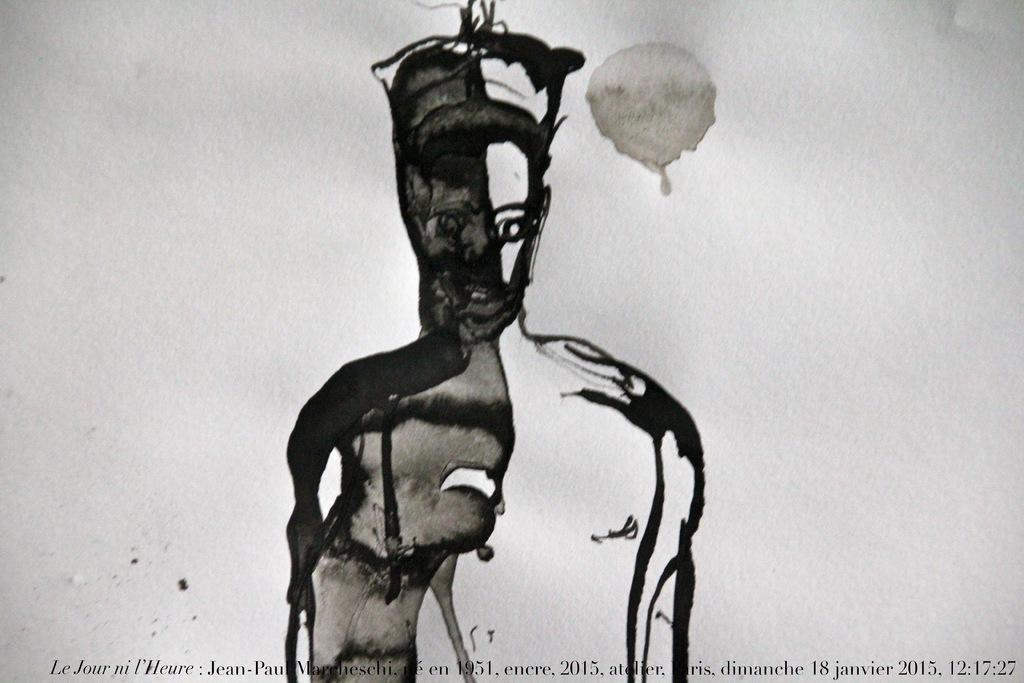What is the color scheme of the image? The image is black and white. What is depicted in the image? There is a drawing of a person in the image. What else can be seen on the paper in the image? There is a drop mark on a paper in the image. What information is provided at the bottom of the image? There is text written at the bottom of the image. What type of brick is being used to build the sandcastle in the image? There is no brick or sandcastle present in the image; it features a black and white drawing of a person with a drop mark on a paper and text at the bottom. 